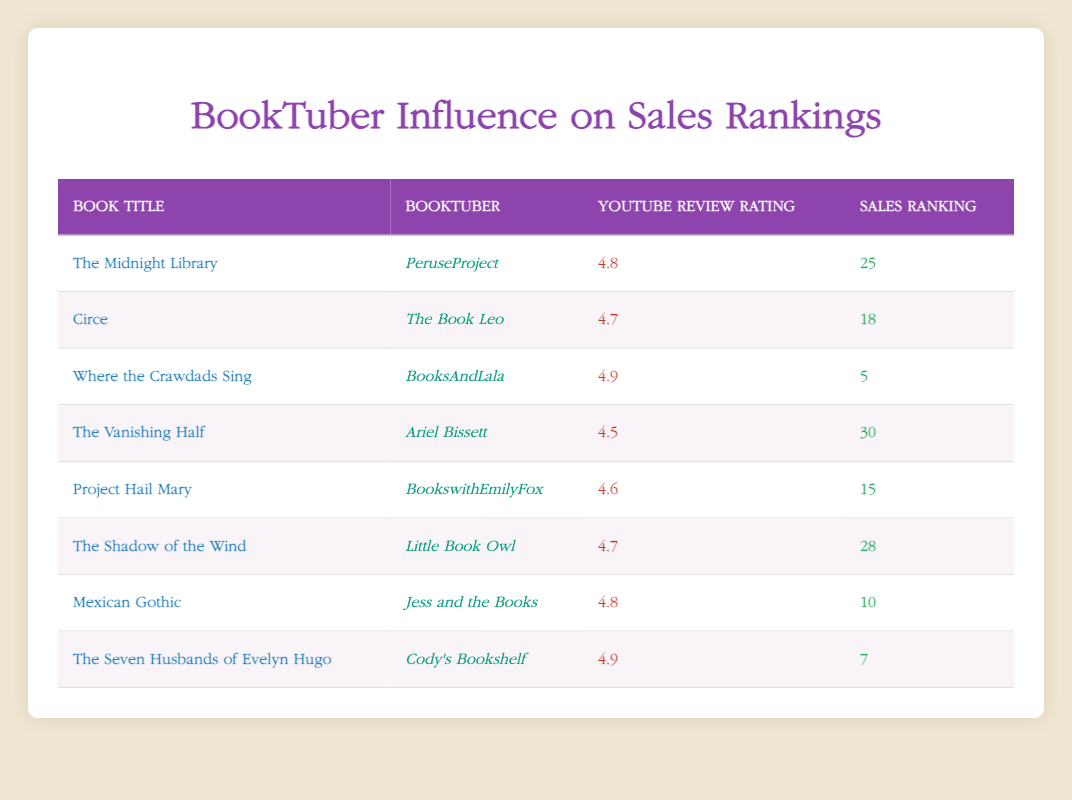What is the highest YouTube review rating in the table? The table shows the YouTube review ratings for each book. Scanning through the ratings, the highest rating is 4.9, which appears for "Where the Crawdads Sing" and "The Seven Husbands of Evelyn Hugo."
Answer: 4.9 Which book had the lowest sales ranking in the table? The sales rankings are listed next to each book. By reviewing the rankings, "Where the Crawdads Sing" has the lowest sales ranking of 5.
Answer: Where the Crawdads Sing Is the relationship between YouTube review rating and sales ranking positive or negative? Looking at the data, as the YouTube review ratings increase, the sales rankings (where a lower number is better) tend to decrease, indicating a negative correlation.
Answer: Negative What is the average YouTube review rating of the books listed in the table? To find the average, we sum all the ratings: 4.8 + 4.7 + 4.9 + 4.5 + 4.6 + 4.7 + 4.8 + 4.9 = 37.9. There are 8 books, so the average rating is 37.9 / 8 = 4.7375, which rounds to approximately 4.74.
Answer: 4.74 Which booktuber gave a review rating of 4.6? By scanning the table, we find that "BookswithEmilyFox" gave a review rating of 4.6 for "Project Hail Mary."
Answer: BookswithEmilyFox How many books have a YouTube review rating above 4.7? Reviewing the ratings, the books with ratings above 4.7 are: "The Midnight Library” (4.8), "Where the Crawdads Sing" (4.9), "Mexican Gothic" (4.8), and "The Seven Husbands of Evelyn Hugo" (4.9). There are a total of 4 books fitting this criterion.
Answer: 4 Is there any book with both a YouTube review rating of 4.5 and a sales ranking higher than 25? In the table, "The Vanishing Half" has a review rating of 4.5 and a sales ranking of 30, which is higher than 25. Therefore, the statement is true.
Answer: Yes What is the median sales ranking of the books reviewed? To find the median, we first list the sales rankings in ascending order: 5, 7, 10, 15, 18, 25, 28, 30. The median is the average of the 4th and 5th values (15 and 18). So, (15 + 18) / 2 = 16.5.
Answer: 16.5 